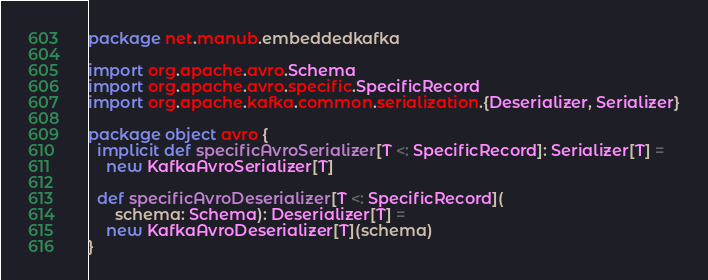<code> <loc_0><loc_0><loc_500><loc_500><_Scala_>package net.manub.embeddedkafka

import org.apache.avro.Schema
import org.apache.avro.specific.SpecificRecord
import org.apache.kafka.common.serialization.{Deserializer, Serializer}

package object avro {
  implicit def specificAvroSerializer[T <: SpecificRecord]: Serializer[T] =
    new KafkaAvroSerializer[T]

  def specificAvroDeserializer[T <: SpecificRecord](
      schema: Schema): Deserializer[T] =
    new KafkaAvroDeserializer[T](schema)
}
</code> 